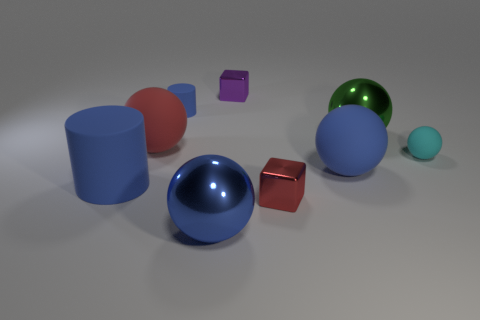Add 1 small shiny blocks. How many objects exist? 10 Subtract all blue rubber balls. How many balls are left? 4 Subtract 1 cubes. How many cubes are left? 1 Subtract all blue balls. How many balls are left? 3 Subtract all cubes. How many objects are left? 7 Subtract all yellow cubes. How many blue balls are left? 2 Add 9 purple objects. How many purple objects are left? 10 Add 8 blue cylinders. How many blue cylinders exist? 10 Subtract 0 yellow cubes. How many objects are left? 9 Subtract all cyan cylinders. Subtract all purple balls. How many cylinders are left? 2 